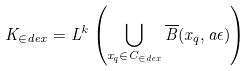<formula> <loc_0><loc_0><loc_500><loc_500>K _ { \in d e x } = L ^ { k } \left ( \bigcup _ { x _ { q } \in C _ { \in d e x } } \overline { B } ( x _ { q } , a \epsilon ) \right )</formula> 